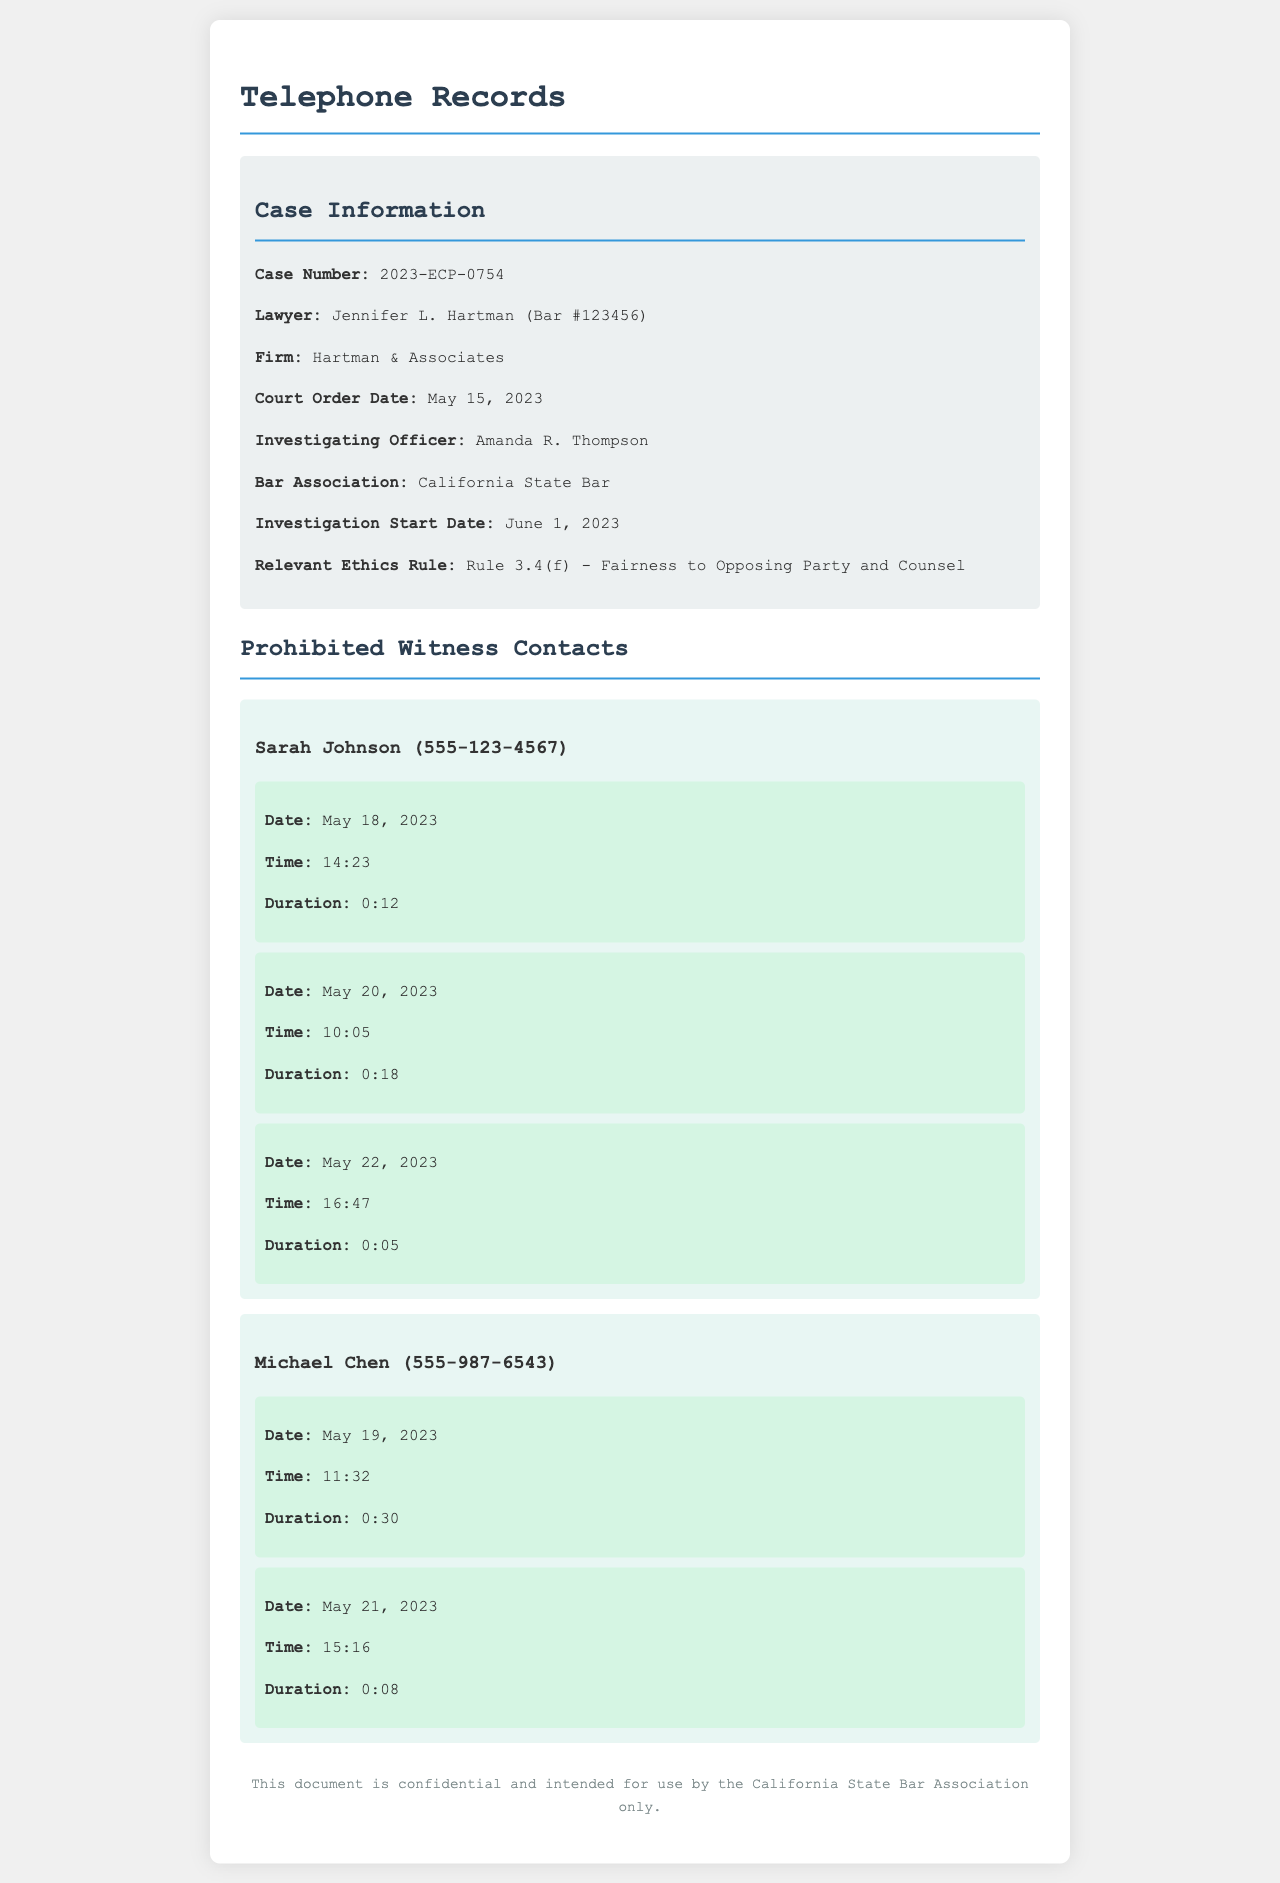what is the name of the lawyer involved in the case? The document states that the lawyer is Jennifer L. Hartman.
Answer: Jennifer L. Hartman what is the case number? The case number is provided in the case information section.
Answer: 2023-ECP-0754 when did the court order get issued? The court order date is specified in the document as May 15, 2023.
Answer: May 15, 2023 how many times did Jennifer attempt to contact Sarah Johnson? The document lists three call attempts to Sarah Johnson.
Answer: 3 what was the duration of the first call to Michael Chen? The document indicates the first call to Michael Chen lasted 30 seconds.
Answer: 0:30 which rule is relevant to the investigation? The relevant ethics rule is mentioned in the case information.
Answer: Rule 3.4(f) when did the investigation start? The investigation start date is noted as June 1, 2023.
Answer: June 1, 2023 how many prohibited witnesses are listed? The document details two prohibited witnesses.
Answer: 2 what is the phone number of Sarah Johnson? The phone number for Sarah Johnson is provided in the witness record.
Answer: 555-123-4567 what is the duration of the last call attempt to Sarah Johnson? The duration of the last call attempt to Sarah Johnson is noted in the document as 5 seconds.
Answer: 0:05 